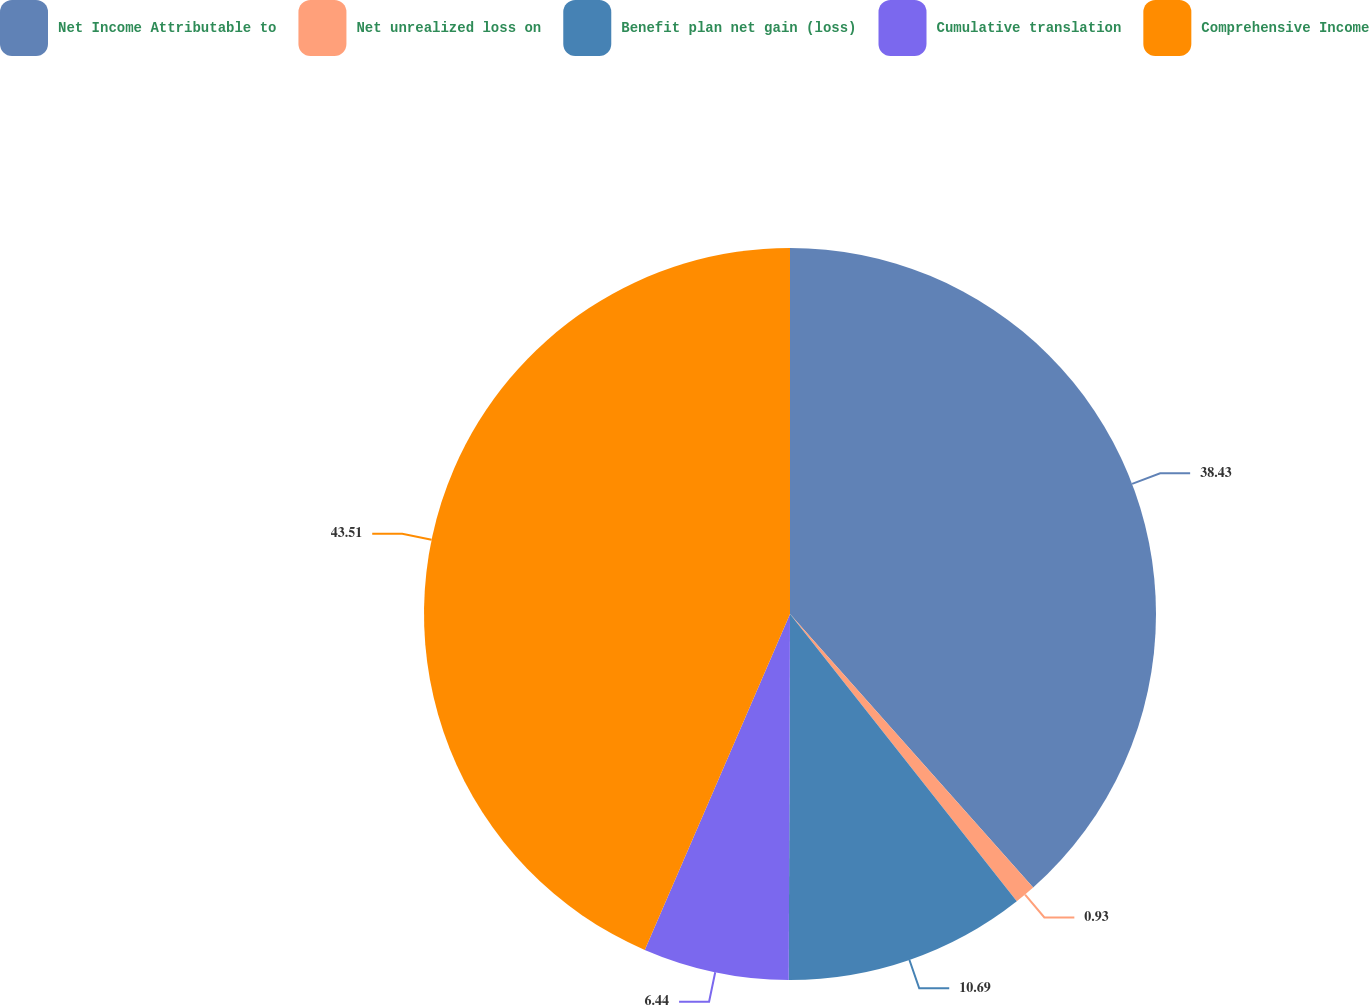<chart> <loc_0><loc_0><loc_500><loc_500><pie_chart><fcel>Net Income Attributable to<fcel>Net unrealized loss on<fcel>Benefit plan net gain (loss)<fcel>Cumulative translation<fcel>Comprehensive Income<nl><fcel>38.43%<fcel>0.93%<fcel>10.69%<fcel>6.44%<fcel>43.5%<nl></chart> 